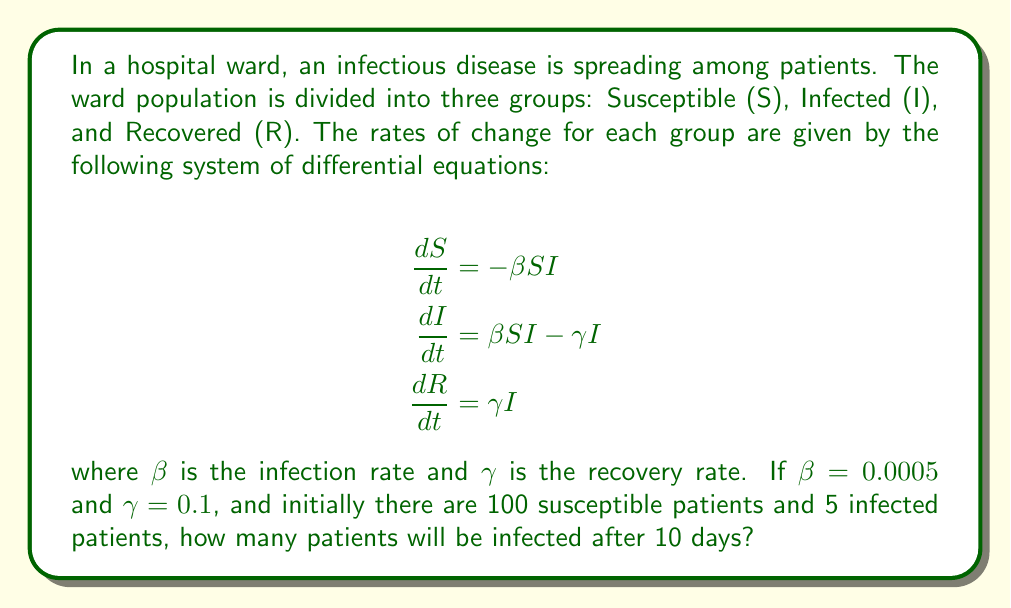Solve this math problem. To solve this problem, we need to use numerical methods to approximate the solution of the system of differential equations. We'll use the Euler method for simplicity.

Step 1: Set up initial conditions and parameters
$S_0 = 100$, $I_0 = 5$, $R_0 = 0$
$\beta = 0.0005$, $\gamma = 0.1$
Time step $\Delta t = 1$ day, Total time $T = 10$ days

Step 2: Implement the Euler method
For each time step $i$ from 0 to 9:
$$\begin{align}
S_{i+1} &= S_i + \Delta t \cdot (-\beta S_i I_i) \\
I_{i+1} &= I_i + \Delta t \cdot (\beta S_i I_i - \gamma I_i) \\
R_{i+1} &= R_i + \Delta t \cdot (\gamma I_i)
\end{align}$$

Step 3: Calculate the values for each day
Day 0: $S = 100$, $I = 5$, $R = 0$
Day 1: $S = 99.75$, $I = 5.225$, $R = 0.5$
Day 2: $S = 99.4875$, $I = 5.4619$, $R = 1.0256$
...
Day 9: $S = 97.0606$, $I = 7.6894$, $R = 5.2500$
Day 10: $S = 96.6955$, $I = 7.9845$, $R = 5.3200$

Step 4: Round the final number of infected patients to the nearest whole number
After 10 days, there will be approximately 8 infected patients.
Answer: 8 infected patients 